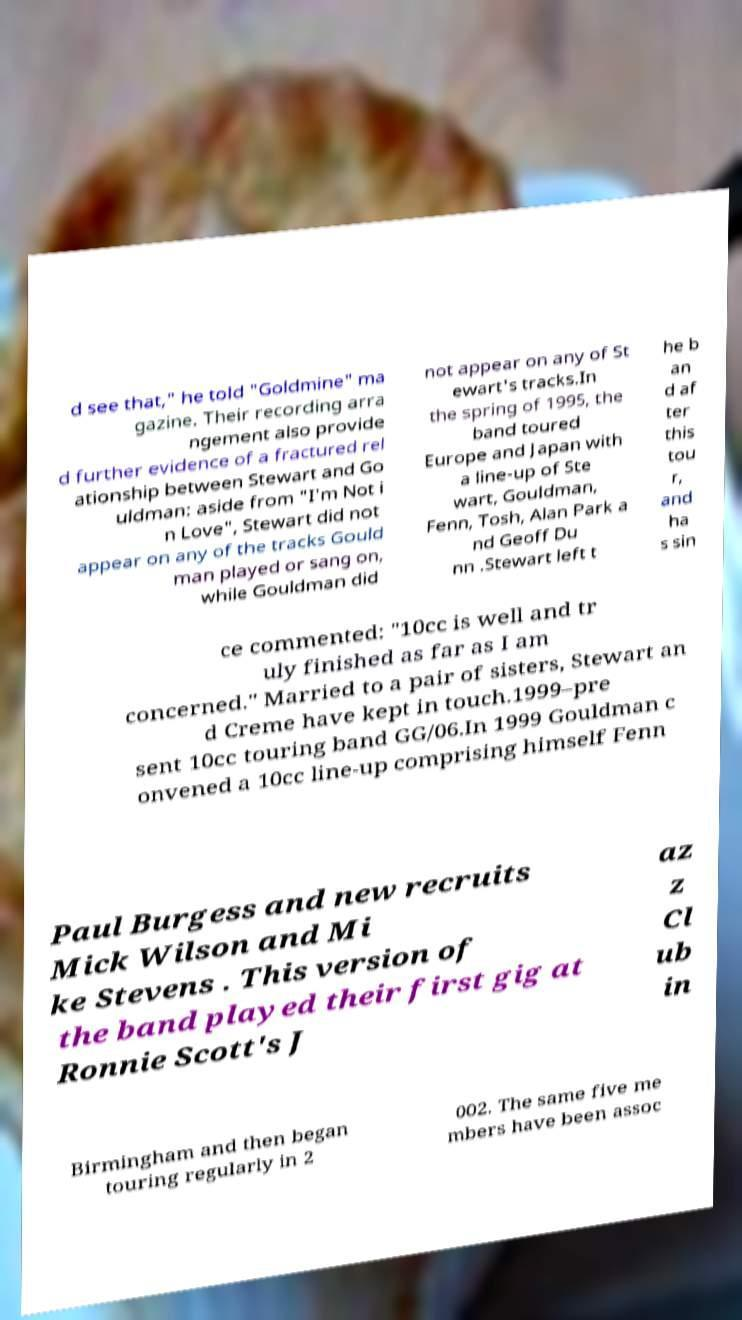Could you extract and type out the text from this image? d see that," he told "Goldmine" ma gazine. Their recording arra ngement also provide d further evidence of a fractured rel ationship between Stewart and Go uldman: aside from "I'm Not i n Love", Stewart did not appear on any of the tracks Gould man played or sang on, while Gouldman did not appear on any of St ewart's tracks.In the spring of 1995, the band toured Europe and Japan with a line-up of Ste wart, Gouldman, Fenn, Tosh, Alan Park a nd Geoff Du nn .Stewart left t he b an d af ter this tou r, and ha s sin ce commented: "10cc is well and tr uly finished as far as I am concerned." Married to a pair of sisters, Stewart an d Creme have kept in touch.1999–pre sent 10cc touring band GG/06.In 1999 Gouldman c onvened a 10cc line-up comprising himself Fenn Paul Burgess and new recruits Mick Wilson and Mi ke Stevens . This version of the band played their first gig at Ronnie Scott's J az z Cl ub in Birmingham and then began touring regularly in 2 002. The same five me mbers have been assoc 